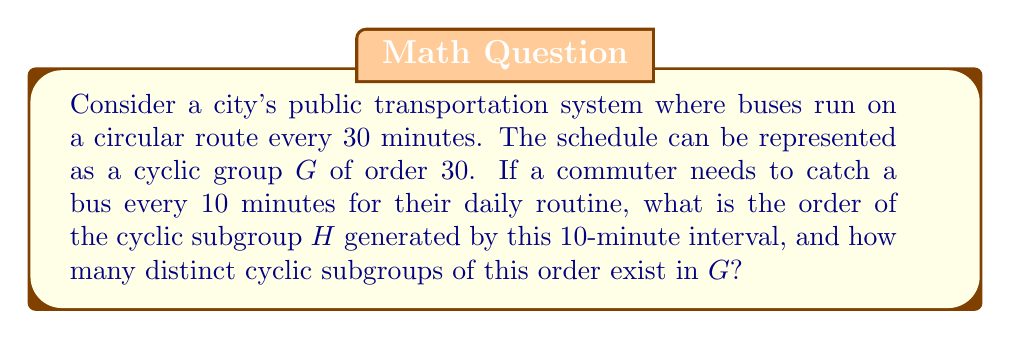What is the answer to this math problem? Let's approach this step-by-step:

1) The main group $G$ represents the bus schedule with a period of 30 minutes. This forms a cyclic group of order 30.

2) The commuter's need to catch a bus every 10 minutes generates a subgroup $H$ of $G$. To find the order of $H$, we need to determine how many times we need to apply the 10-minute interval to get back to the starting point.

3) We can calculate this using the concept of least common multiple (LCM):

   $LCM(10, 30) = 30$

4) This means that after 30 minutes, the 10-minute interval will align with the original schedule. Therefore, the order of subgroup $H$ is:

   $|H| = 30 / 10 = 3$

5) To find how many distinct cyclic subgroups of order 3 exist in $G$, we need to count the number of elements in $G$ that generate a subgroup of order 3.

6) In a cyclic group of order $n$, the number of elements of order $d$ (where $d$ divides $n$) is equal to $\phi(d)$, where $\phi$ is Euler's totient function.

7) In this case, we're looking for elements of order 3 in a group of order 30. The number of such elements is $\phi(3) = 2$.

8) Each of these two elements generates the same subgroup of order 3. Therefore, there is only one distinct cyclic subgroup of order 3 in $G$.
Answer: The cyclic subgroup $H$ has order 3, and there is 1 distinct cyclic subgroup of this order in $G$. 